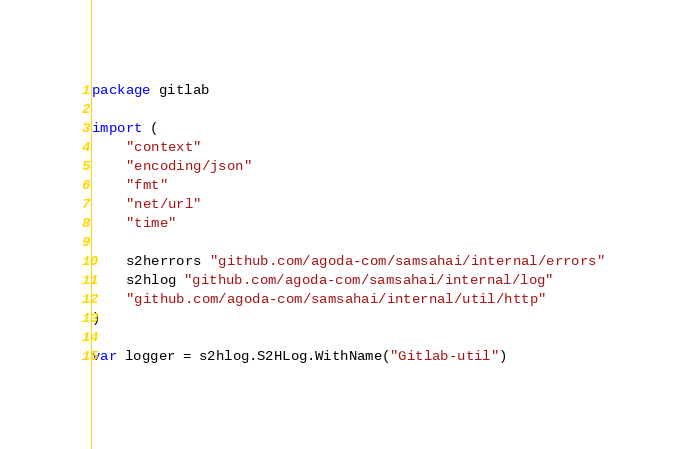Convert code to text. <code><loc_0><loc_0><loc_500><loc_500><_Go_>package gitlab

import (
	"context"
	"encoding/json"
	"fmt"
	"net/url"
	"time"

	s2herrors "github.com/agoda-com/samsahai/internal/errors"
	s2hlog "github.com/agoda-com/samsahai/internal/log"
	"github.com/agoda-com/samsahai/internal/util/http"
)

var logger = s2hlog.S2HLog.WithName("Gitlab-util")
</code> 